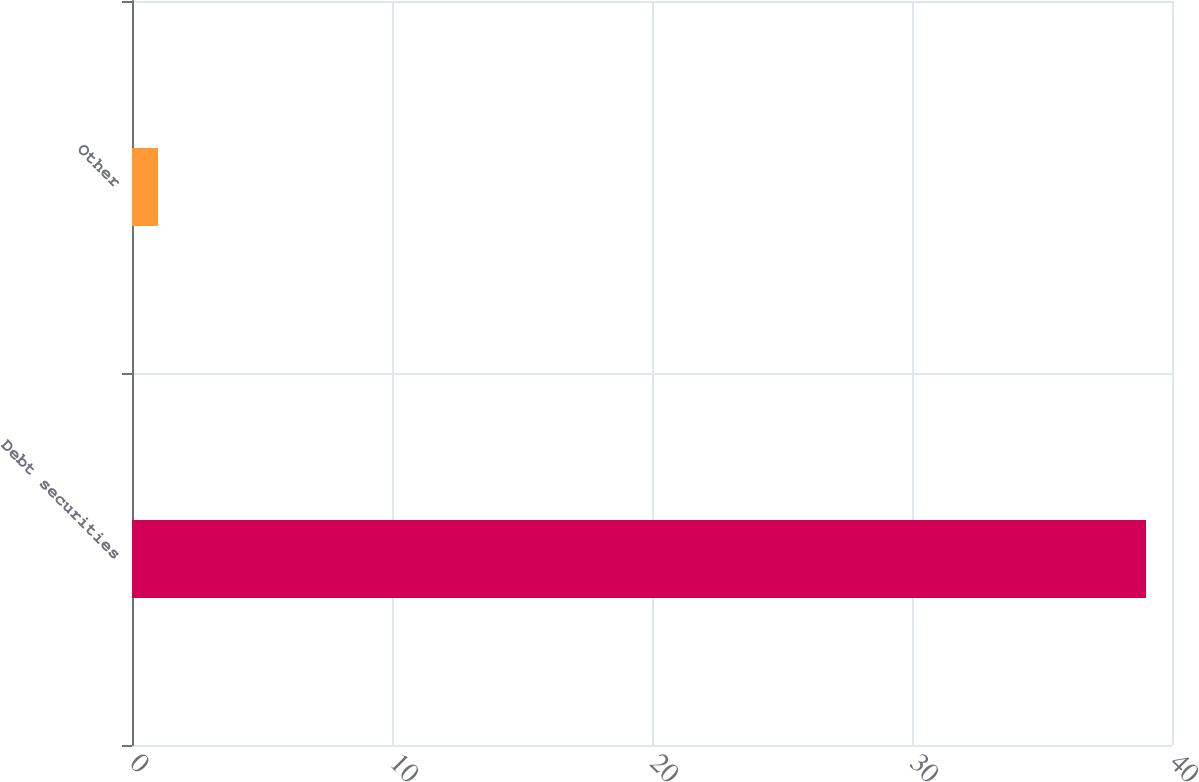Convert chart. <chart><loc_0><loc_0><loc_500><loc_500><bar_chart><fcel>Debt securities<fcel>Other<nl><fcel>39<fcel>1<nl></chart> 